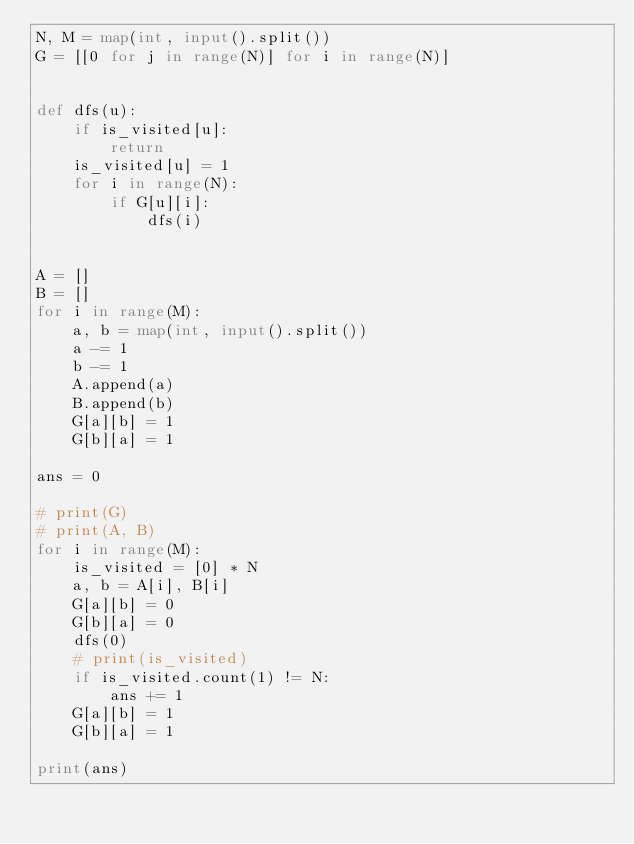<code> <loc_0><loc_0><loc_500><loc_500><_Python_>N, M = map(int, input().split())
G = [[0 for j in range(N)] for i in range(N)]


def dfs(u):
    if is_visited[u]:
        return
    is_visited[u] = 1
    for i in range(N):
        if G[u][i]:
            dfs(i)


A = []
B = []
for i in range(M):
    a, b = map(int, input().split())
    a -= 1
    b -= 1
    A.append(a)
    B.append(b)
    G[a][b] = 1
    G[b][a] = 1

ans = 0

# print(G)
# print(A, B)
for i in range(M):
    is_visited = [0] * N
    a, b = A[i], B[i]
    G[a][b] = 0
    G[b][a] = 0
    dfs(0)
    # print(is_visited)
    if is_visited.count(1) != N:
        ans += 1
    G[a][b] = 1
    G[b][a] = 1

print(ans)

</code> 